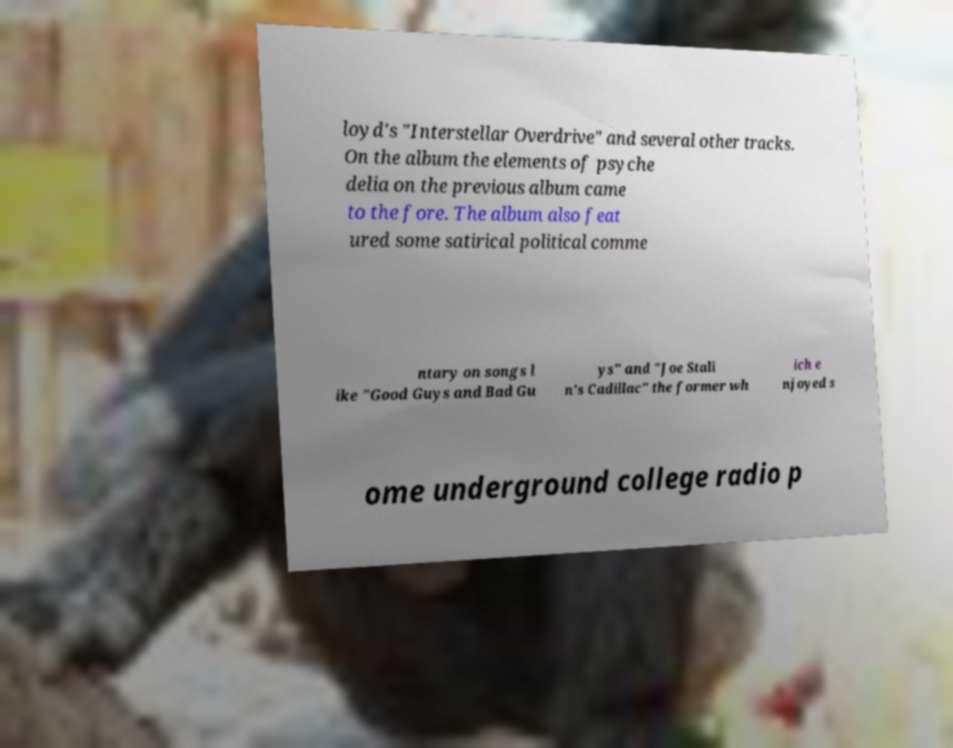Could you extract and type out the text from this image? loyd's "Interstellar Overdrive" and several other tracks. On the album the elements of psyche delia on the previous album came to the fore. The album also feat ured some satirical political comme ntary on songs l ike "Good Guys and Bad Gu ys" and "Joe Stali n's Cadillac" the former wh ich e njoyed s ome underground college radio p 